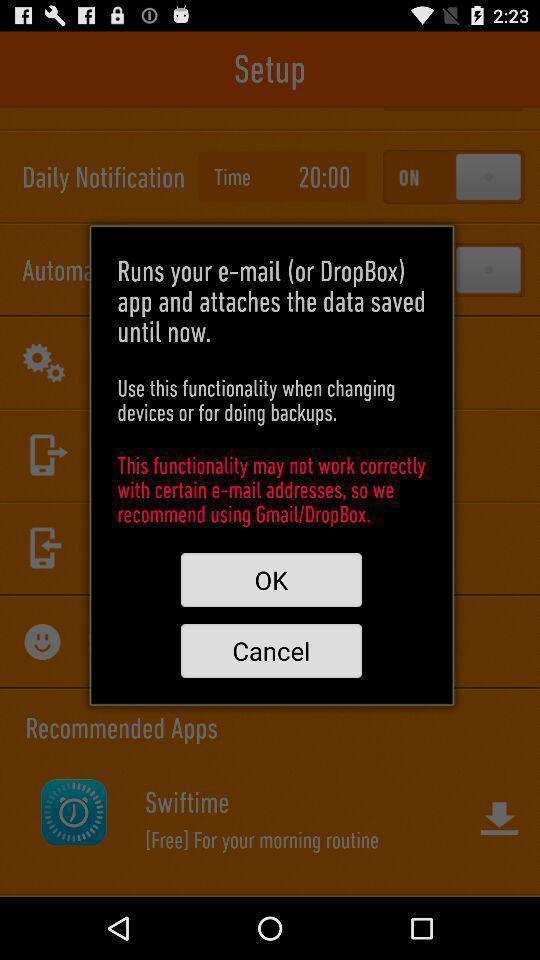Describe the key features of this screenshot. Pop-up showing details of a social app. 